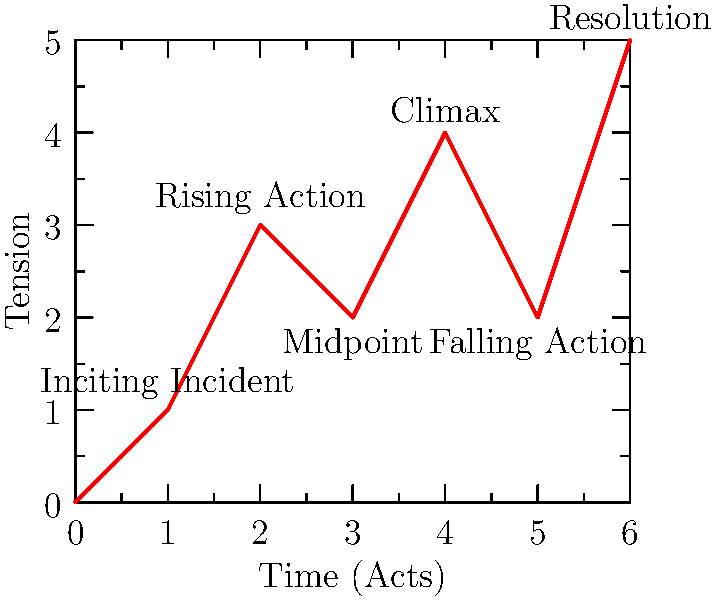In the vector-based timeline of a movie's plot structure shown above, which point represents the highest level of tension before the final resolution? To answer this question, we need to analyze the plot structure timeline:

1. The x-axis represents time progression through the movie's acts.
2. The y-axis represents the level of tension in the story.
3. Each labeled point corresponds to a key moment in the plot structure.

Let's examine each point:
1. Inciting Incident: (1,1) - low tension, story kickoff
2. Rising Action: (2,3) - tension increases
3. Midpoint: (3,2) - slight dip in tension
4. Climax: (4,4) - highest point on the graph before the resolution
5. Falling Action: (5,2) - tension decreases
6. Resolution: (6,5) - final high point, but occurs after the main conflict

The question asks for the highest level of tension before the final resolution. This corresponds to the highest y-value on the graph before the last point. The Climax at (4,4) has the highest y-value (4) before the Resolution point.
Answer: Climax 